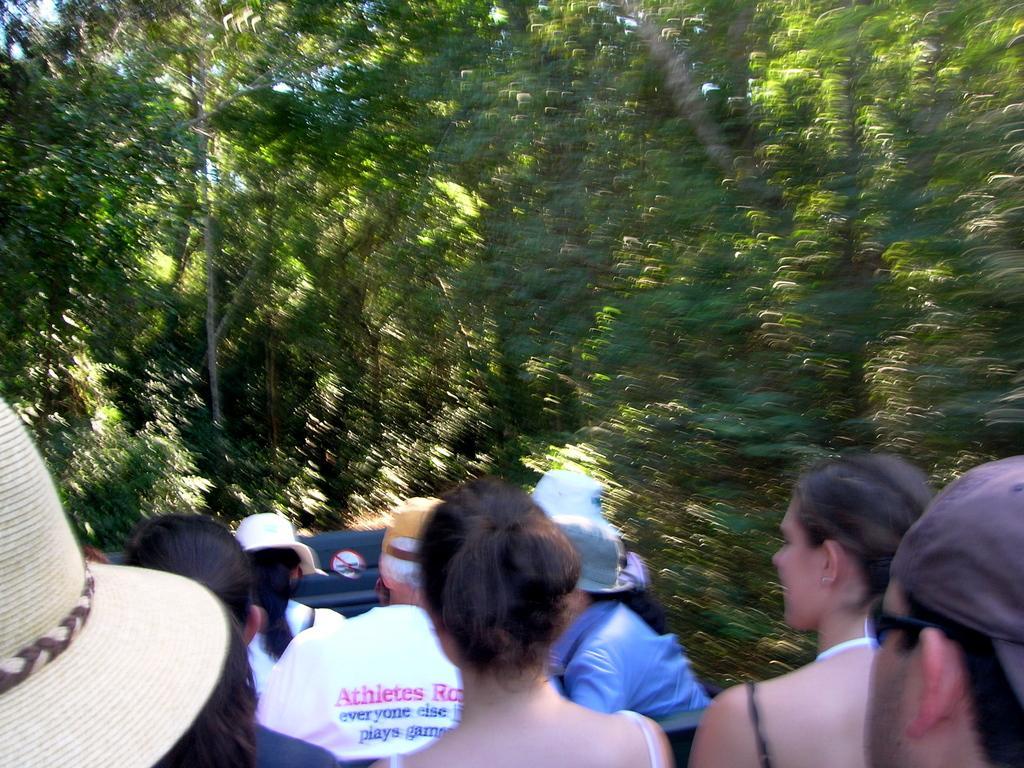Please provide a concise description of this image. At the bottom of the image there are people. In the background of the image there are trees. 